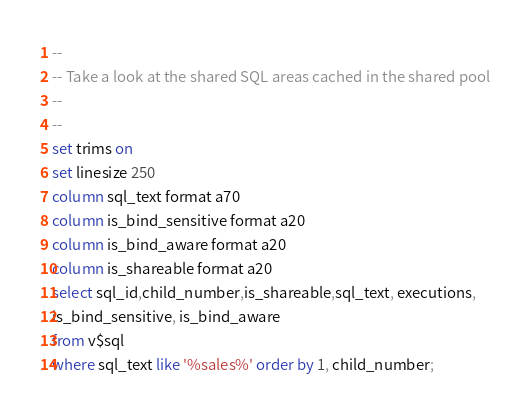Convert code to text. <code><loc_0><loc_0><loc_500><loc_500><_SQL_>--
-- Take a look at the shared SQL areas cached in the shared pool
--
--
set trims on 
set linesize 250
column sql_text format a70
column is_bind_sensitive format a20
column is_bind_aware format a20
column is_shareable format a20
select sql_id,child_number,is_shareable,sql_text, executions,
is_bind_sensitive, is_bind_aware
from v$sql
where sql_text like '%sales%' order by 1, child_number;
</code> 